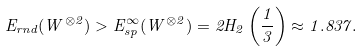Convert formula to latex. <formula><loc_0><loc_0><loc_500><loc_500>E _ { r n d } ( W ^ { \otimes 2 } ) > E ^ { \infty } _ { s p } ( W ^ { \otimes 2 } ) = 2 H _ { 2 } \left ( \frac { 1 } { 3 } \right ) \approx 1 . 8 3 7 .</formula> 